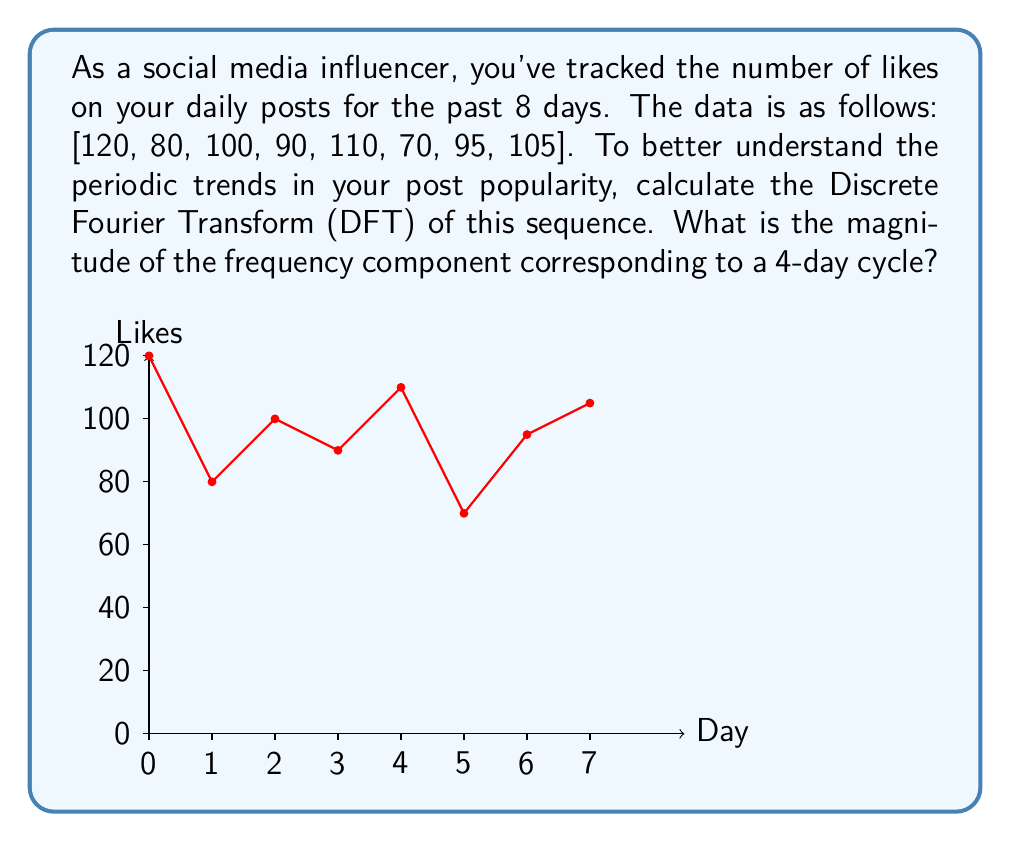Can you solve this math problem? To solve this problem, we'll follow these steps:

1) The Discrete Fourier Transform (DFT) of a sequence $x[n]$ of length N is given by:

   $$X[k] = \sum_{n=0}^{N-1} x[n] e^{-i2\pi kn/N}$$

2) In this case, N = 8, and we're interested in the component for a 4-day cycle, which corresponds to k = 2 (as 8/4 = 2).

3) Let's calculate X[2]:

   $$X[2] = \sum_{n=0}^{7} x[n] e^{-i2\pi 2n/8}$$

4) Expanding this:

   $$X[2] = 120e^{-i\pi 0} + 80e^{-i\pi 1/2} + 100e^{-i\pi} + 90e^{-i3\pi/2} + 110e^{-i2\pi} + 70e^{-i5\pi/2} + 95e^{-i3\pi} + 105e^{-i7\pi/2}$$

5) Simplify using Euler's formula ($e^{i\theta} = \cos\theta + i\sin\theta$):

   $$X[2] = (120 - 100 + 110 - 95) + i(80 - 90 + 70 - 105) = 35 - 45i$$

6) The magnitude of this complex number is given by:

   $$|X[2]| = \sqrt{35^2 + (-45)^2} = \sqrt{3250} \approx 57.01$$

Therefore, the magnitude of the frequency component corresponding to a 4-day cycle is approximately 57.01.
Answer: 57.01 